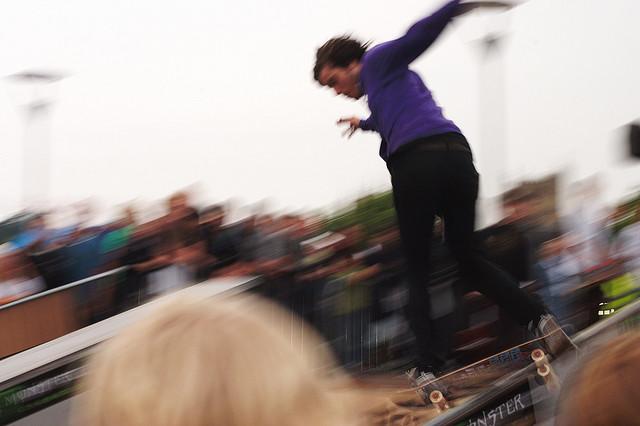Did this person pose for the photo?
Be succinct. No. What is the color of the skater's shirt?
Give a very brief answer. Purple. What animal is being used in the show?
Be succinct. None. Does this look a game at the fair?
Be succinct. No. Is the crowd blurry?
Quick response, please. Yes. What is the person riding?
Give a very brief answer. Skateboard. 